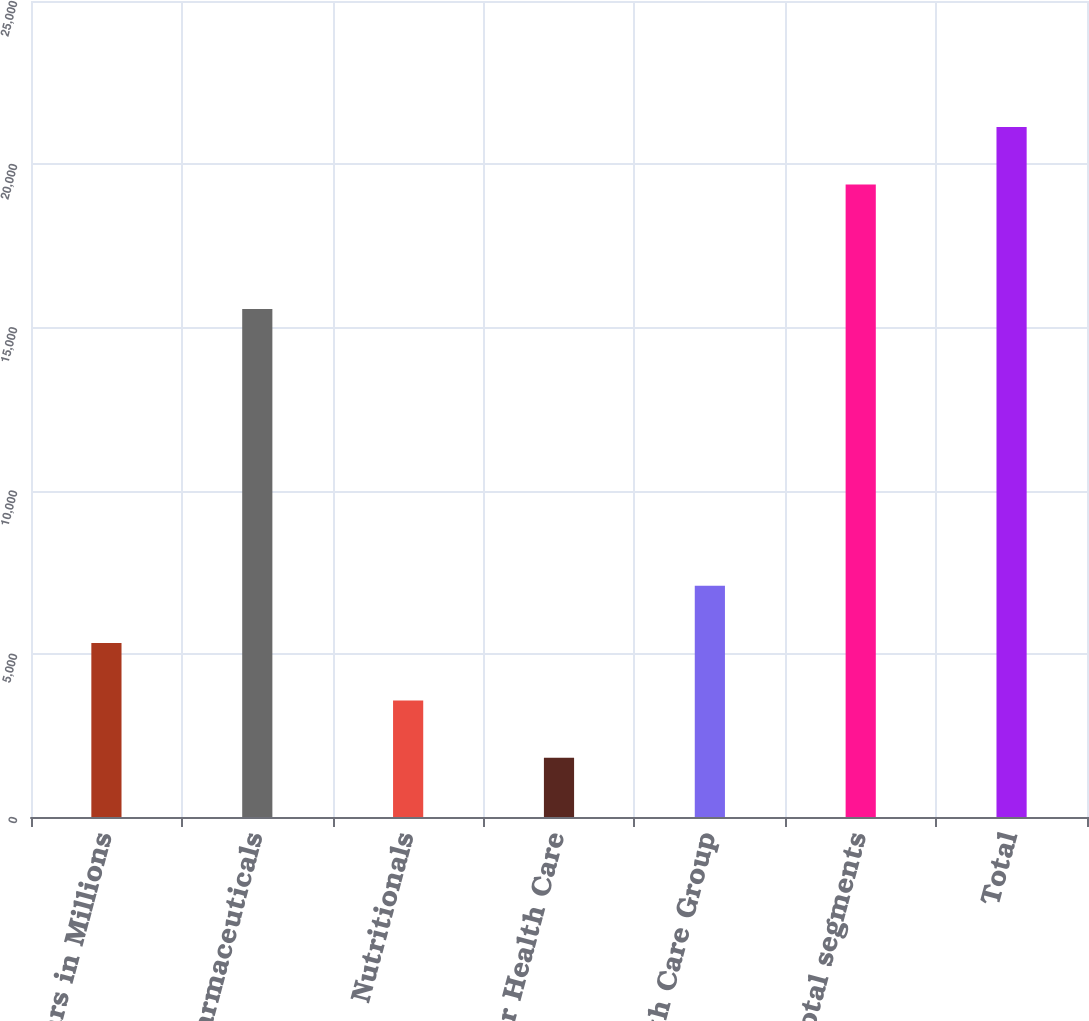Convert chart. <chart><loc_0><loc_0><loc_500><loc_500><bar_chart><fcel>Dollars in Millions<fcel>Pharmaceuticals<fcel>Nutritionals<fcel>Other Health Care<fcel>Health Care Group<fcel>Total segments<fcel>Total<nl><fcel>5328<fcel>15564<fcel>3571.5<fcel>1815<fcel>7084.5<fcel>19380<fcel>21136.5<nl></chart> 